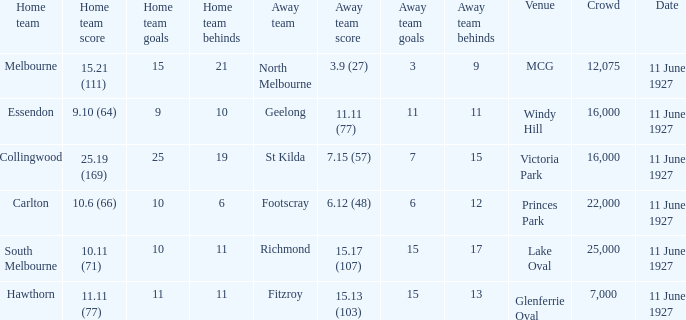What was the overall attendance in all the crowds at the mcg site? 12075.0. 